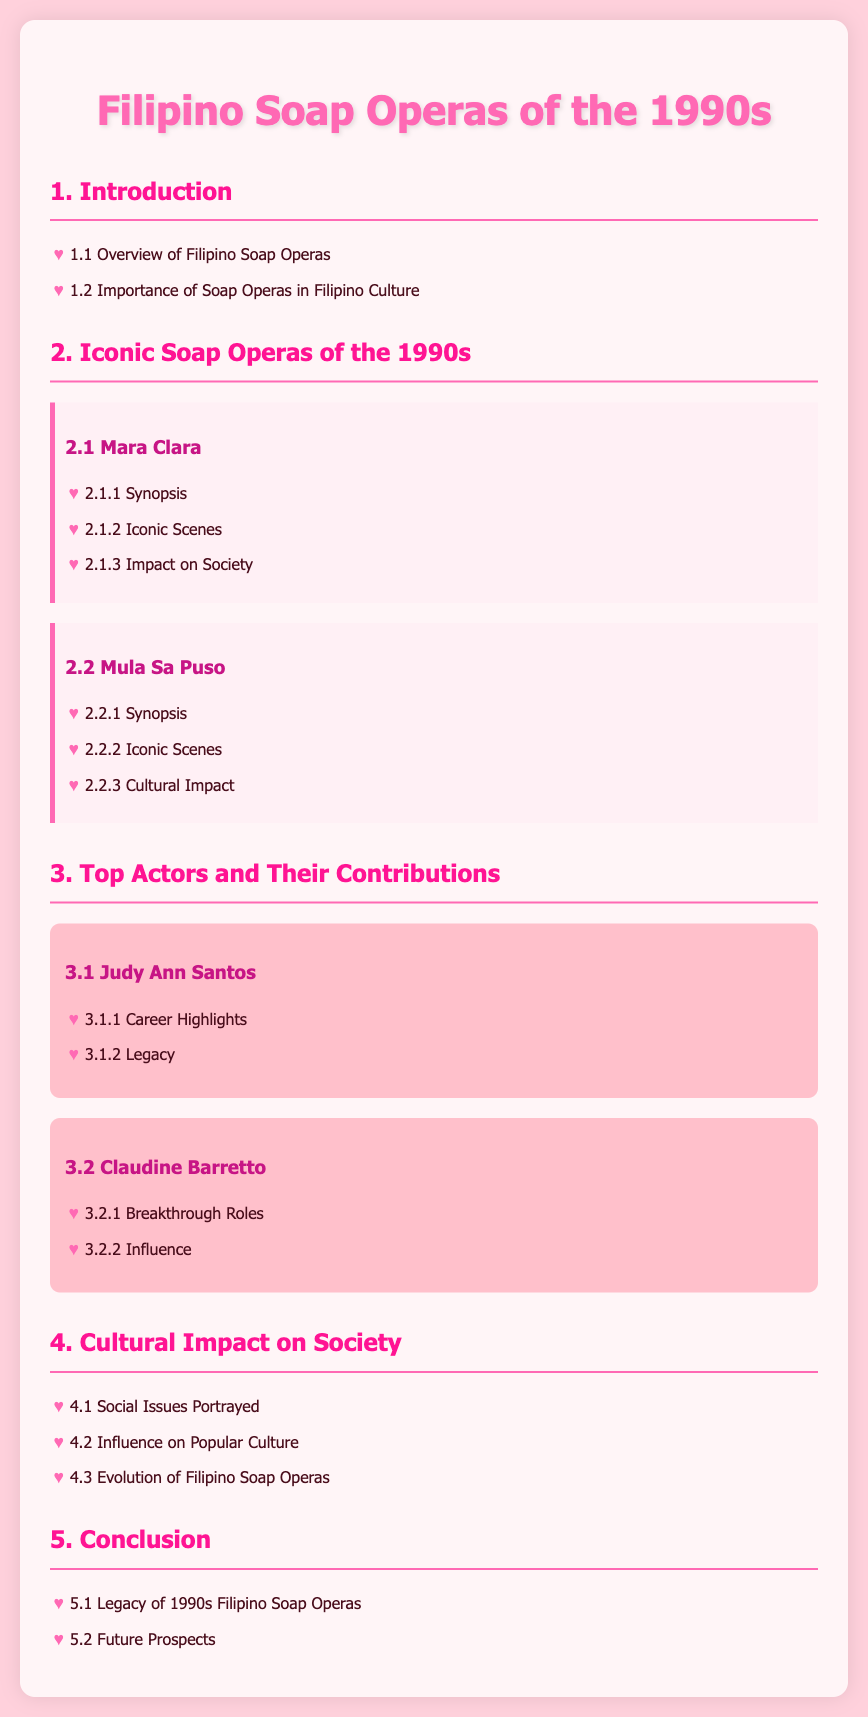What is the title of the document? The title is specified in the <title> tag of the HTML document.
Answer: Filipino Soap Operas of the 1990s What are some iconic soap operas from the 1990s? The iconic soap operas are listed under section 2.
Answer: Mara Clara, Mula Sa Puso Who is mentioned as a top actor in the document? The top actors are highlighted in section 3.
Answer: Judy Ann Santos What is one social issue portrayed in the soap operas? Social issues are discussed in section 4.1.
Answer: Social Issues Portrayed How many sections are there in the document? The total number of sections can be counted from the main headings in the document.
Answer: 5 What is the legacy of 1990s Filipino soap operas? The legacy is outlined in section 5.1.
Answer: Legacy of 1990s Filipino Soap Operas What is a characteristic color for the title in the document? The color is defined in the CSS styling for the h1 element.
Answer: #ff69b4 